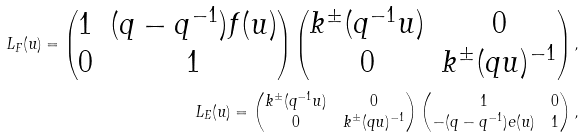<formula> <loc_0><loc_0><loc_500><loc_500>L _ { F } ( u ) = \begin{pmatrix} 1 & ( q - q ^ { - 1 } ) f ( u ) \\ 0 & 1 \end{pmatrix} \begin{pmatrix} k ^ { \pm } ( q ^ { - 1 } u ) & 0 \\ 0 & k ^ { \pm } ( q u ) ^ { - 1 } \end{pmatrix} , \\ L _ { E } ( u ) = \begin{pmatrix} k ^ { \pm } ( q ^ { - 1 } u ) & 0 \\ 0 & k ^ { \pm } ( q u ) ^ { - 1 } \end{pmatrix} \begin{pmatrix} 1 & 0 \\ - ( q - q ^ { - 1 } ) e ( u ) & 1 \end{pmatrix} ,</formula> 